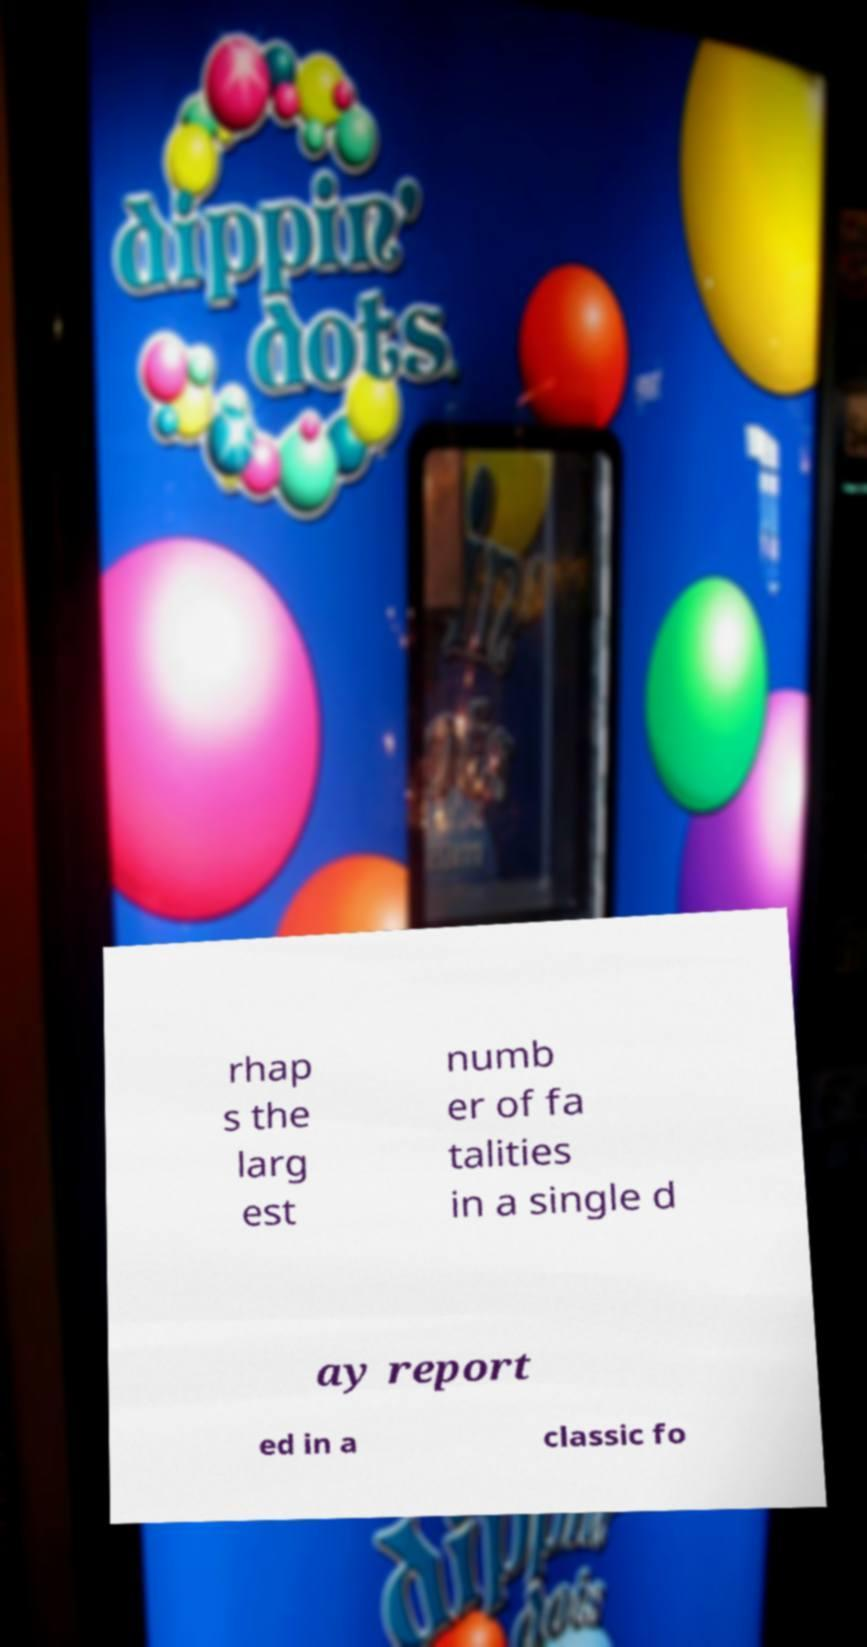There's text embedded in this image that I need extracted. Can you transcribe it verbatim? rhap s the larg est numb er of fa talities in a single d ay report ed in a classic fo 